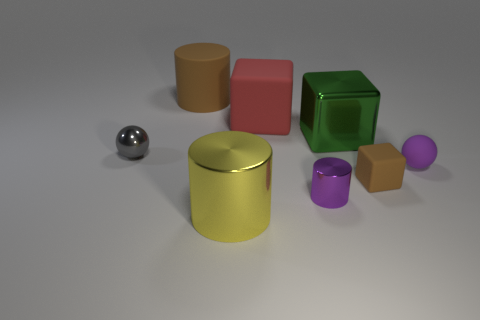What is the brown thing to the left of the brown block made of?
Your answer should be compact. Rubber. What number of rubber things are both behind the big green shiny thing and on the right side of the large green object?
Keep it short and to the point. 0. There is a yellow cylinder that is the same size as the red object; what is it made of?
Provide a short and direct response. Metal. There is a ball that is left of the large matte cylinder; is it the same size as the shiny cylinder that is behind the yellow cylinder?
Give a very brief answer. Yes. There is a tiny cylinder; are there any rubber things on the right side of it?
Provide a short and direct response. Yes. There is a large cylinder that is in front of the tiny purple object behind the brown rubber cube; what color is it?
Offer a terse response. Yellow. Are there fewer tiny shiny cylinders than brown things?
Provide a succinct answer. Yes. How many other tiny metallic things have the same shape as the purple shiny object?
Make the answer very short. 0. There is another metallic cylinder that is the same size as the brown cylinder; what color is it?
Provide a short and direct response. Yellow. Are there the same number of yellow objects that are left of the green metal thing and brown matte cylinders that are in front of the yellow cylinder?
Offer a very short reply. No. 